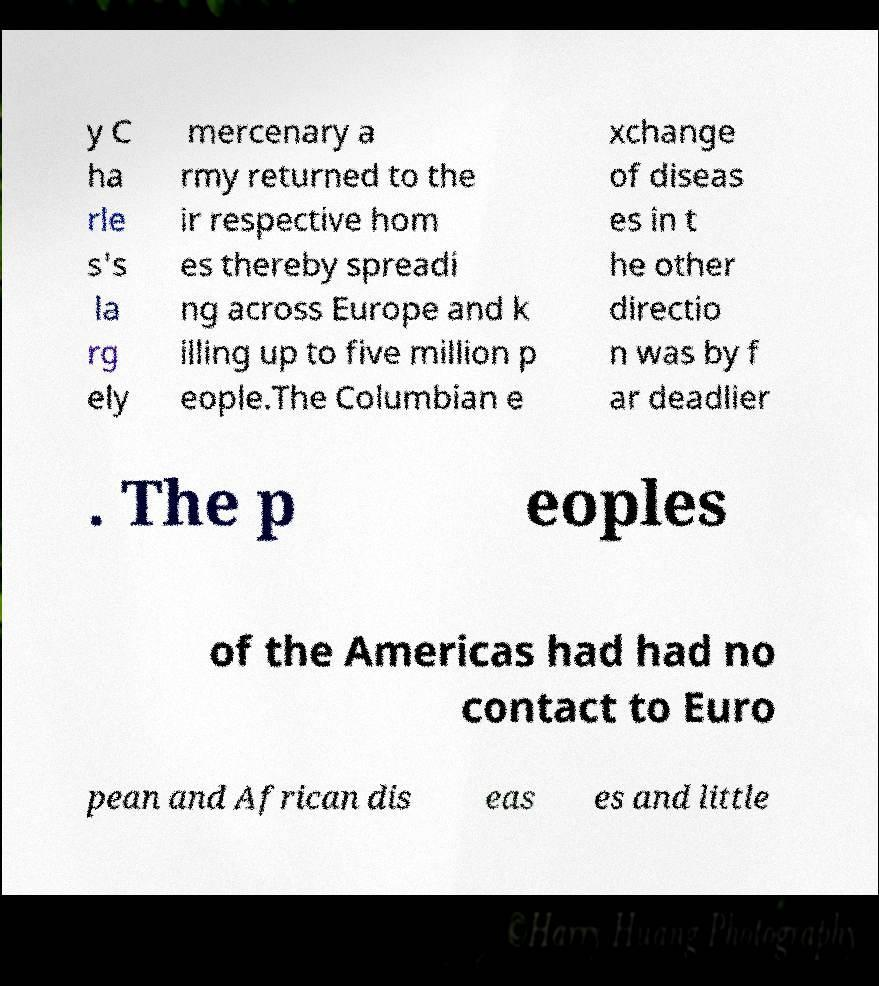Can you read and provide the text displayed in the image?This photo seems to have some interesting text. Can you extract and type it out for me? y C ha rle s's la rg ely mercenary a rmy returned to the ir respective hom es thereby spreadi ng across Europe and k illing up to five million p eople.The Columbian e xchange of diseas es in t he other directio n was by f ar deadlier . The p eoples of the Americas had had no contact to Euro pean and African dis eas es and little 